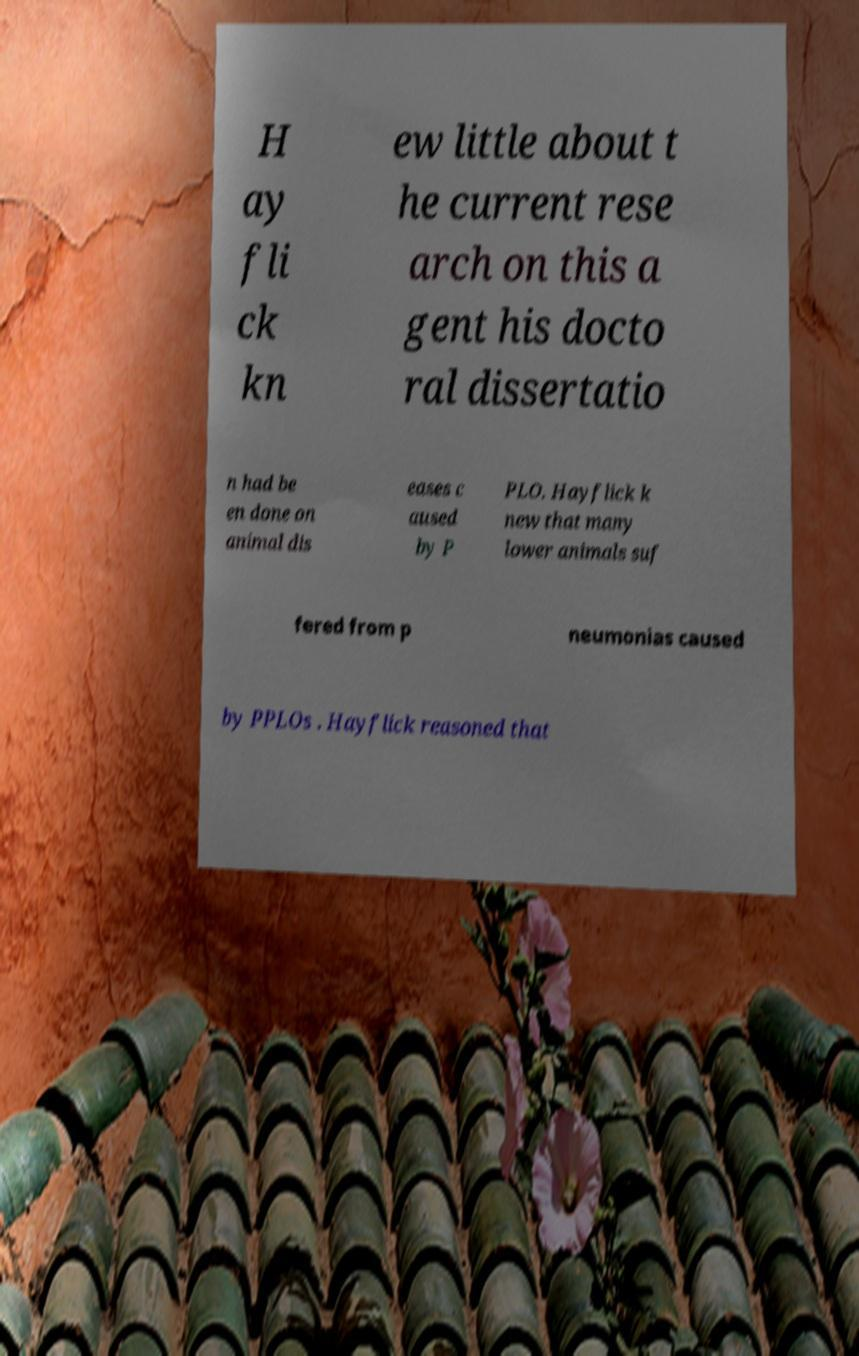For documentation purposes, I need the text within this image transcribed. Could you provide that? H ay fli ck kn ew little about t he current rese arch on this a gent his docto ral dissertatio n had be en done on animal dis eases c aused by P PLO. Hayflick k new that many lower animals suf fered from p neumonias caused by PPLOs . Hayflick reasoned that 